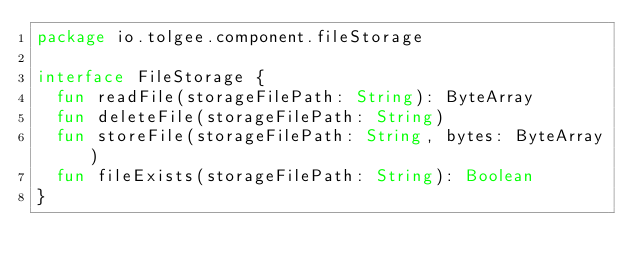Convert code to text. <code><loc_0><loc_0><loc_500><loc_500><_Kotlin_>package io.tolgee.component.fileStorage

interface FileStorage {
  fun readFile(storageFilePath: String): ByteArray
  fun deleteFile(storageFilePath: String)
  fun storeFile(storageFilePath: String, bytes: ByteArray)
  fun fileExists(storageFilePath: String): Boolean
}
</code> 